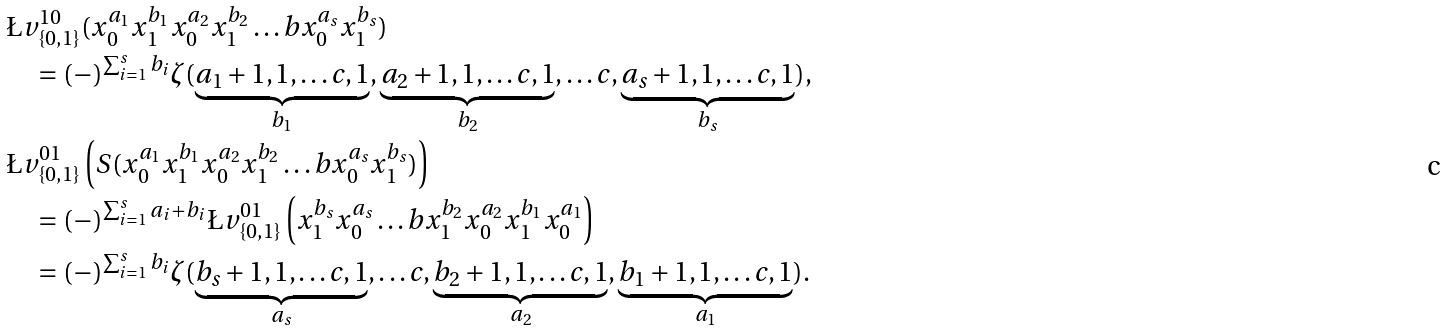Convert formula to latex. <formula><loc_0><loc_0><loc_500><loc_500>& \L v _ { \{ 0 , 1 \} } ^ { 1 0 } ( { x _ { 0 } ^ { a _ { 1 } } x _ { 1 } ^ { b _ { 1 } } x _ { 0 } ^ { a _ { 2 } } x _ { 1 } ^ { b _ { 2 } } \dots b x _ { 0 } ^ { a _ { s } } x _ { 1 } ^ { b _ { s } } } ) \\ & \quad = ( - ) ^ { \sum _ { i = 1 } ^ { s } b _ { i } } \zeta ( \underbrace { a _ { 1 } + 1 , 1 , \dots c , 1 } _ { b _ { 1 } } , \underbrace { a _ { 2 } + 1 , 1 , \dots c , 1 } _ { b _ { 2 } } , \dots c , \underbrace { a _ { s } + 1 , 1 , \dots c , 1 } _ { b _ { s } } ) , \\ & \L v _ { \{ 0 , 1 \} } ^ { 0 1 } \left ( S ( { x _ { 0 } ^ { a _ { 1 } } x _ { 1 } ^ { b _ { 1 } } x _ { 0 } ^ { a _ { 2 } } x _ { 1 } ^ { b _ { 2 } } \dots b x _ { 0 } ^ { a _ { s } } x _ { 1 } ^ { b _ { s } } } ) \right ) \\ & \quad = ( - ) ^ { \sum _ { i = 1 } ^ { s } a _ { i } + b _ { i } } \L v _ { \{ 0 , 1 \} } ^ { 0 1 } \left ( { x _ { 1 } ^ { b _ { s } } x _ { 0 } ^ { a _ { s } } \dots b x _ { 1 } ^ { b _ { 2 } } x _ { 0 } ^ { a _ { 2 } } x _ { 1 } ^ { b _ { 1 } } x _ { 0 } ^ { a _ { 1 } } } \right ) \\ & \quad = ( - ) ^ { \sum _ { i = 1 } ^ { s } b _ { i } } \zeta ( \underbrace { b _ { s } + 1 , 1 , \dots c , 1 } _ { a _ { s } } , \dots c , \underbrace { b _ { 2 } + 1 , 1 , \dots c , 1 } _ { a _ { 2 } } , \underbrace { b _ { 1 } + 1 , 1 , \dots c , 1 } _ { a _ { 1 } } ) .</formula> 